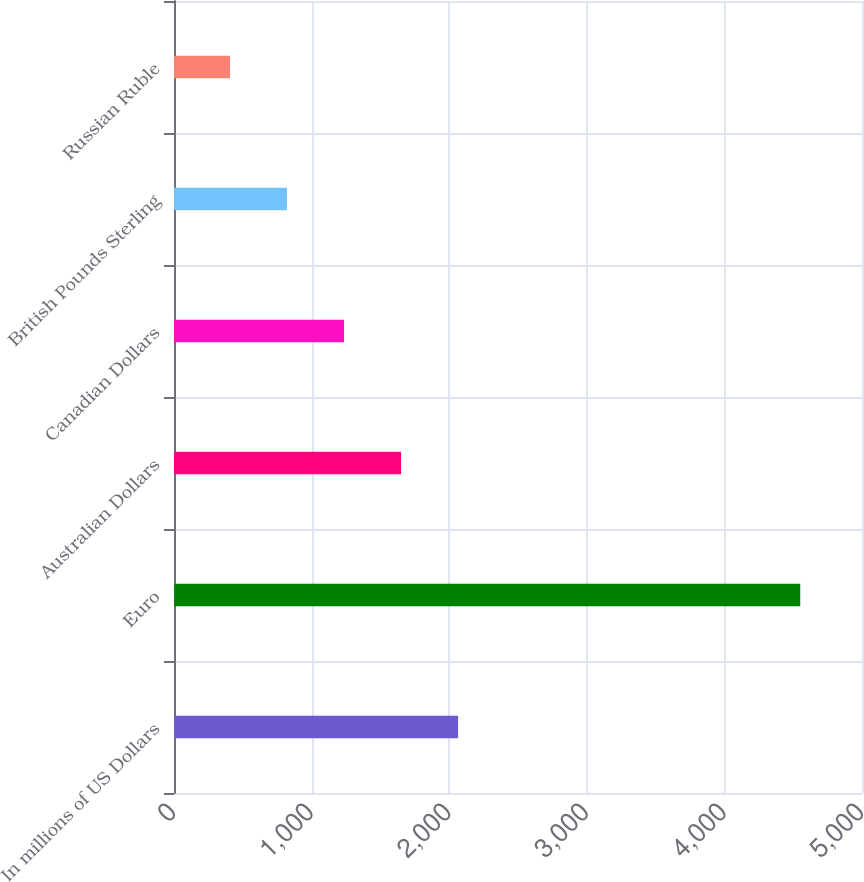<chart> <loc_0><loc_0><loc_500><loc_500><bar_chart><fcel>In millions of US Dollars<fcel>Euro<fcel>Australian Dollars<fcel>Canadian Dollars<fcel>British Pounds Sterling<fcel>Russian Ruble<nl><fcel>2064.6<fcel>4551<fcel>1650.2<fcel>1235.8<fcel>821.4<fcel>407<nl></chart> 